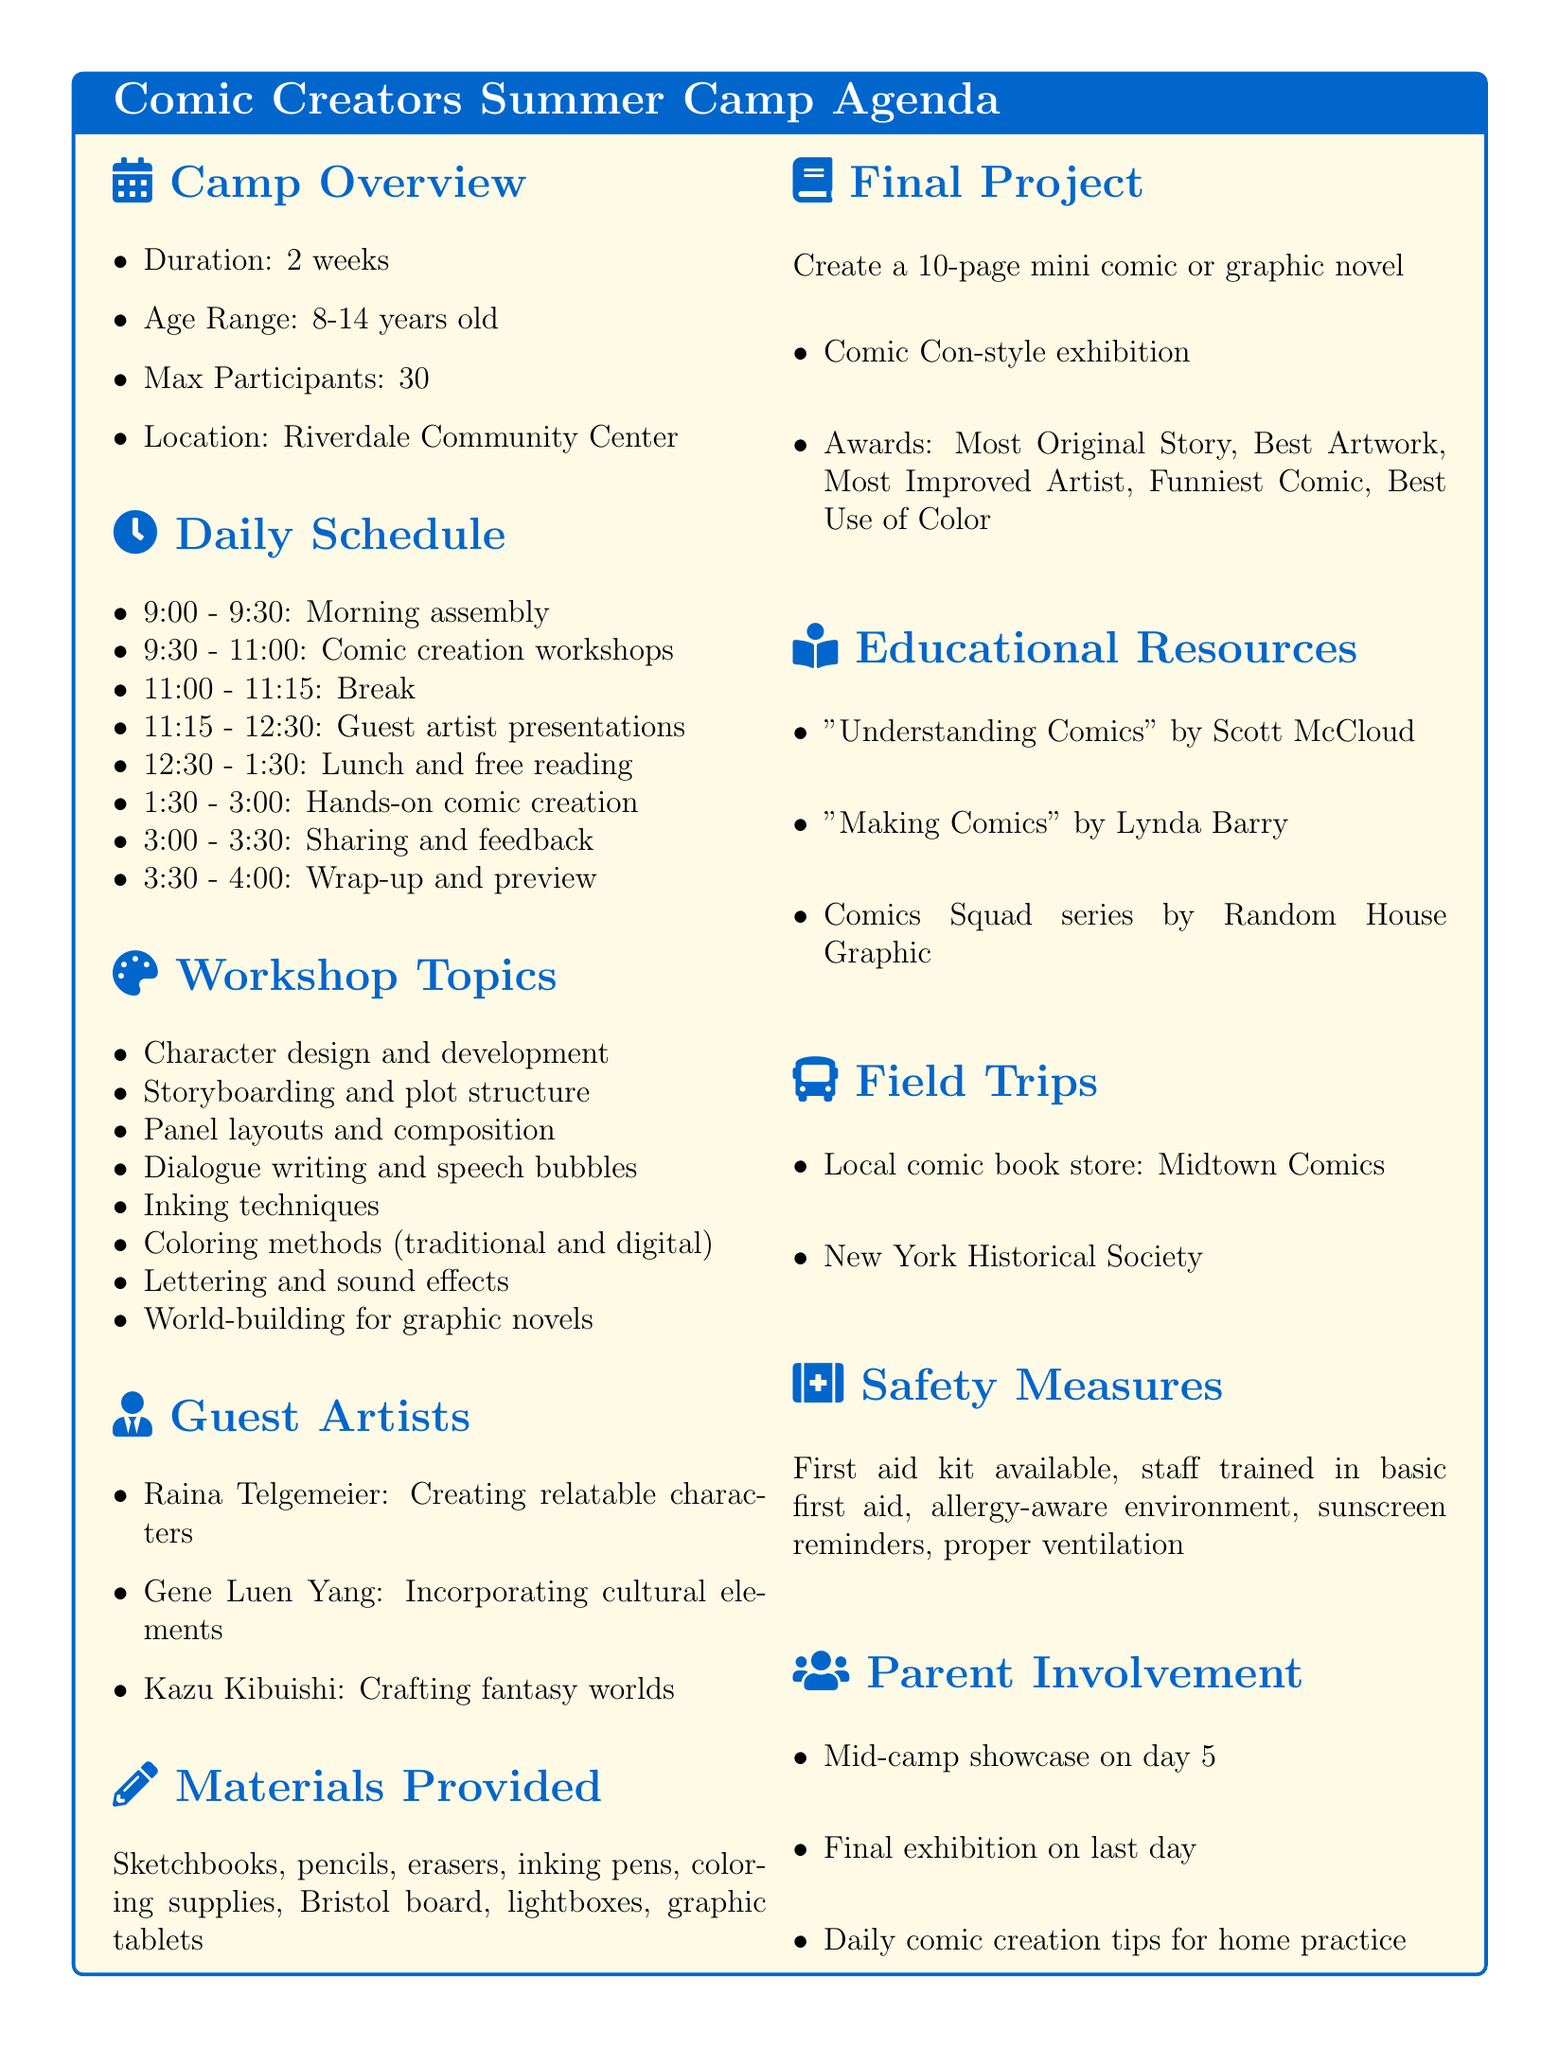What is the name of the summer camp? The name of the summer camp is found in the camp overview section of the document.
Answer: Comic Creators Summer Camp What is the age range for camp participants? The age range for participants is specified in the camp overview section.
Answer: 8-14 years old How many maximum participants are allowed? The maximum number of participants is mentioned in the camp overview.
Answer: 30 What activity occurs between 1:30 PM and 3:00 PM? The daily schedule lists activities, and this time slot is specified for hands-on comic creation.
Answer: Hands-on comic creation Who is a guest artist known for "Smile"? The guest artists section provides the known works for each artist, making it clear who is known for "Smile".
Answer: Raina Telgemeier What is the final project description? The document details the final project specifically in the final project section.
Answer: Create a 10-page mini comic or graphic novel What are the awards categories for the final project? The awards categories for the final project are listed explicitly in the final project section.
Answer: Most Original Story, Best Artwork, Most Improved Artist, Funniest Comic, Best Use of Color Where is the camp located? The location of the camp is specified in the camp overview.
Answer: Riverdale Community Center Which educational resource is authored by Scott McCloud? The educational resources section lists various titles along with their authors.
Answer: Understanding Comics 